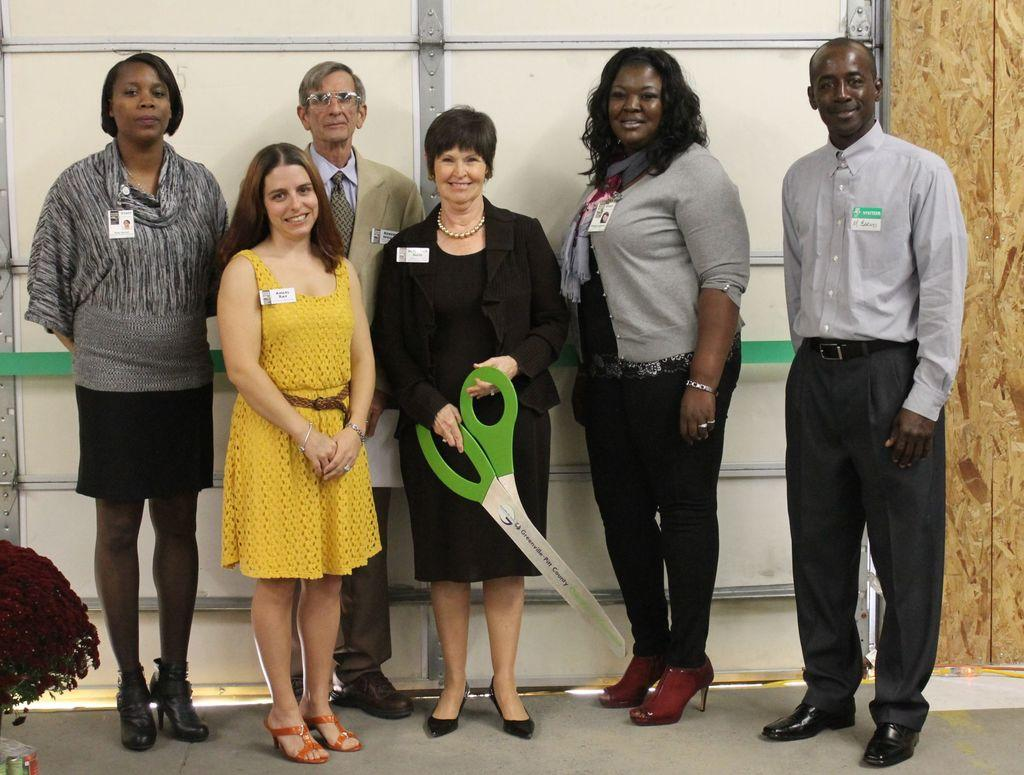How many people are present in the image? There are six persons standing in the image. What are the people wearing that can be seen in the image? The persons are wearing badges. Can you describe the action of one of the ladies in the image? One lady is holding scissors. What can be seen on the left side of the image? There is a flower bouquet on the left side of the image. What is visible in the background of the image? There is a wall visible in the background of the image. What type of swing can be seen in the image? There is no swing present in the image. What color is the snake that is wrapped around the lady holding scissors? There is no snake present in the image; one lady is holding scissors, but there is no mention of a snake. 